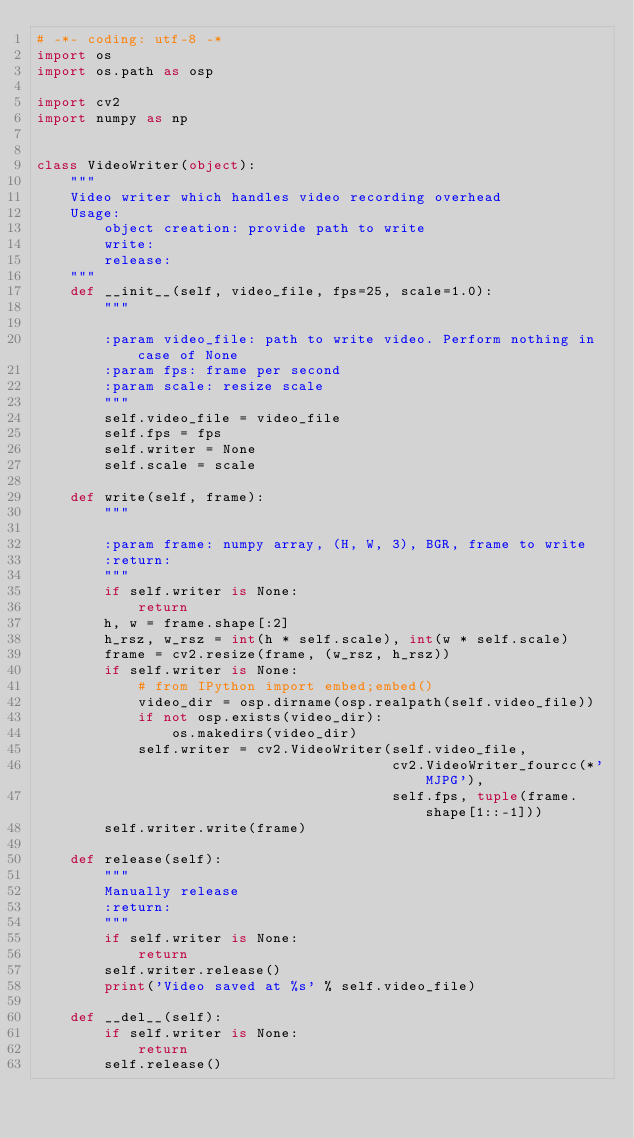<code> <loc_0><loc_0><loc_500><loc_500><_Python_># -*- coding: utf-8 -*
import os
import os.path as osp

import cv2
import numpy as np


class VideoWriter(object):
    """
    Video writer which handles video recording overhead
    Usage:
        object creation: provide path to write
        write:
        release:
    """
    def __init__(self, video_file, fps=25, scale=1.0):
        """

        :param video_file: path to write video. Perform nothing in case of None
        :param fps: frame per second
        :param scale: resize scale
        """
        self.video_file = video_file
        self.fps = fps
        self.writer = None
        self.scale = scale

    def write(self, frame):
        """

        :param frame: numpy array, (H, W, 3), BGR, frame to write
        :return:
        """
        if self.writer is None:
            return
        h, w = frame.shape[:2]
        h_rsz, w_rsz = int(h * self.scale), int(w * self.scale)
        frame = cv2.resize(frame, (w_rsz, h_rsz))
        if self.writer is None:
            # from IPython import embed;embed()
            video_dir = osp.dirname(osp.realpath(self.video_file))
            if not osp.exists(video_dir):
                os.makedirs(video_dir)
            self.writer = cv2.VideoWriter(self.video_file,
                                          cv2.VideoWriter_fourcc(*'MJPG'),
                                          self.fps, tuple(frame.shape[1::-1]))
        self.writer.write(frame)

    def release(self):
        """
        Manually release
        :return:
        """
        if self.writer is None:
            return
        self.writer.release()
        print('Video saved at %s' % self.video_file)

    def __del__(self):
        if self.writer is None:
            return
        self.release()
</code> 